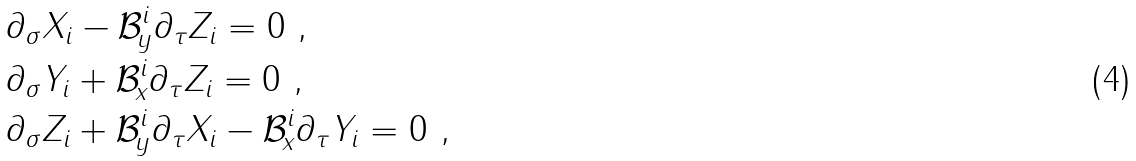Convert formula to latex. <formula><loc_0><loc_0><loc_500><loc_500>& \partial _ { \sigma } X _ { i } - \mathcal { B } _ { y } ^ { i } \partial _ { \tau } Z _ { i } = 0 \ , \\ & \partial _ { \sigma } Y _ { i } + \mathcal { B } _ { x } ^ { i } \partial _ { \tau } Z _ { i } = 0 \ , \\ & \partial _ { \sigma } Z _ { i } + \mathcal { B } _ { y } ^ { i } \partial _ { \tau } X _ { i } - \mathcal { B } _ { x } ^ { i } \partial _ { \tau } Y _ { i } = 0 \ ,</formula> 